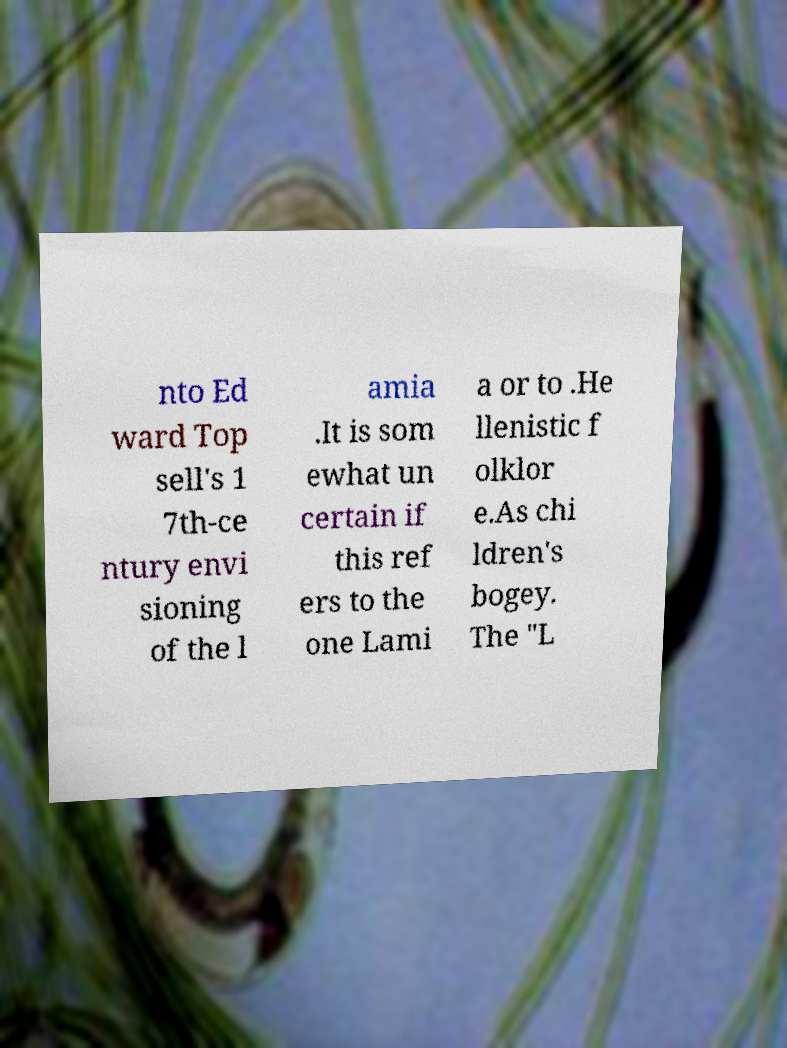There's text embedded in this image that I need extracted. Can you transcribe it verbatim? nto Ed ward Top sell's 1 7th-ce ntury envi sioning of the l amia .It is som ewhat un certain if this ref ers to the one Lami a or to .He llenistic f olklor e.As chi ldren's bogey. The "L 